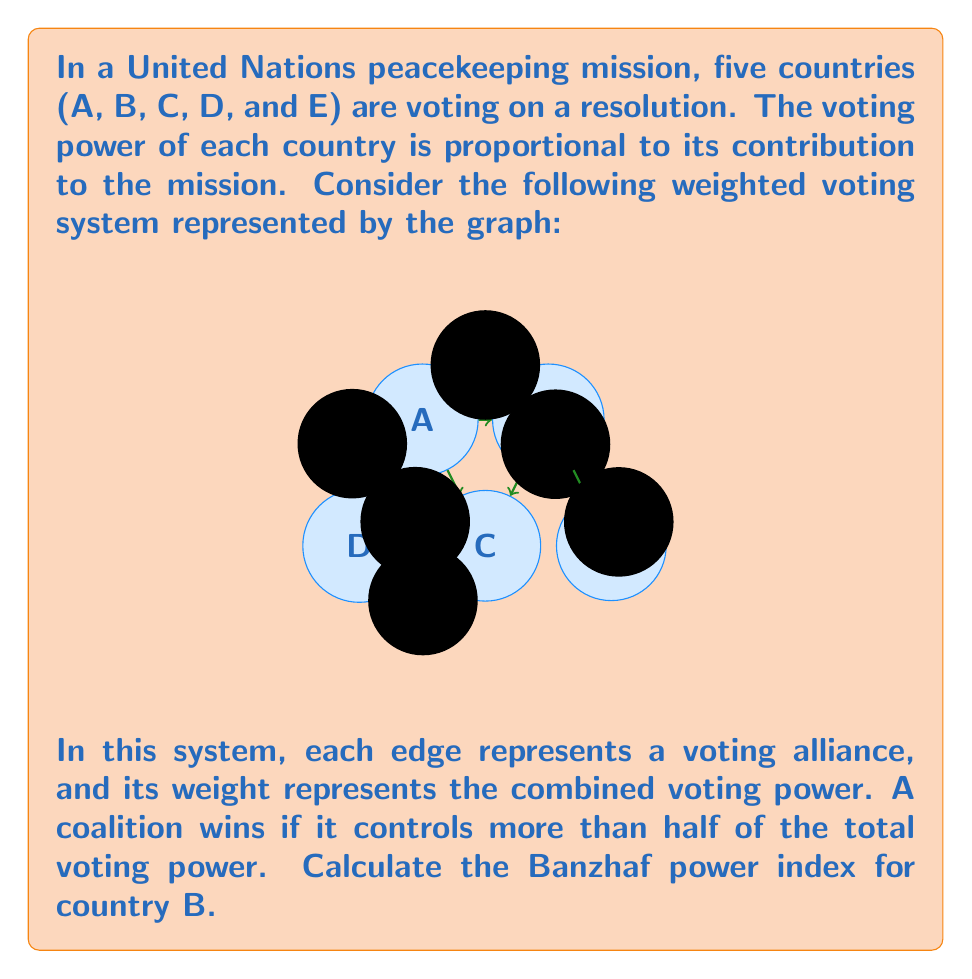Teach me how to tackle this problem. To solve this problem, we'll follow these steps:

1) First, we need to calculate the total voting power in the system:
   $$(3 + 2 + 1 + 2 + 1 + 2) = 11$$

2) A winning coalition needs more than half of the total power:
   $$\frac{11}{2} = 5.5$$
   So, any coalition with 6 or more voting power wins.

3) Now, we need to identify all winning coalitions that include B:
   - AB (3)
   - BC (2)
   - BE (2)
   - ABC (5)
   - ABD (5)
   - ABE (5)
   - BCE (4)
   - ABCD (6)
   - ABCE (6)
   - ABDE (7)
   - BCDE (5)
   - ABCDE (8)

4) Among these, we need to count the critical coalitions for B (where B's removal would make the coalition lose):
   - ABCD (6 - 2 = 4, which is losing)
   - ABCE (6 - 2 = 4, which is losing)
   - ABDE (7 - 2 = 5, which is losing)

5) The Banzhaf power index is calculated as the number of times a country is critical divided by the total number of times any country is critical.

6) We need to count critical coalitions for other countries:
   A is critical in 4 coalitions
   B is critical in 3 coalitions
   C is critical in 1 coalition
   D is critical in 1 coalition
   E is critical in 1 coalition

7) Total number of critical coalitions: 4 + 3 + 1 + 1 + 1 = 10

8) Banzhaf power index for B = $\frac{3}{10} = 0.3$
Answer: 0.3 